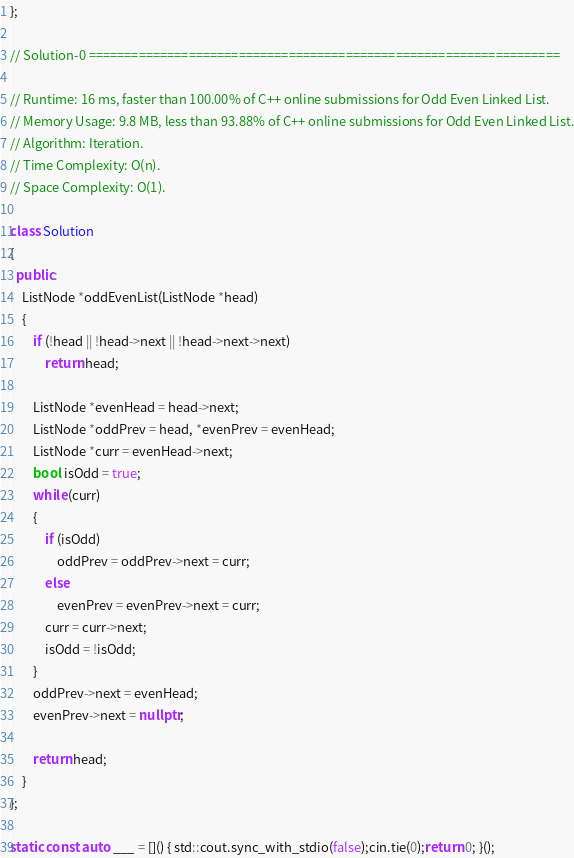Convert code to text. <code><loc_0><loc_0><loc_500><loc_500><_C++_>};

// Solution-0 ==================================================================

// Runtime: 16 ms, faster than 100.00% of C++ online submissions for Odd Even Linked List.
// Memory Usage: 9.8 MB, less than 93.88% of C++ online submissions for Odd Even Linked List.
// Algorithm: Iteration.
// Time Complexity: O(n).
// Space Complexity: O(1).

class Solution
{
  public:
    ListNode *oddEvenList(ListNode *head)
    {
        if (!head || !head->next || !head->next->next)
            return head;

        ListNode *evenHead = head->next;
        ListNode *oddPrev = head, *evenPrev = evenHead;
        ListNode *curr = evenHead->next;
        bool isOdd = true;
        while (curr)
        {
            if (isOdd)
                oddPrev = oddPrev->next = curr;
            else
                evenPrev = evenPrev->next = curr;
            curr = curr->next;
            isOdd = !isOdd;
        }
        oddPrev->next = evenHead;
        evenPrev->next = nullptr;

        return head;
    }
};

static const auto ___ = []() { std::cout.sync_with_stdio(false);cin.tie(0);return 0; }();
</code> 